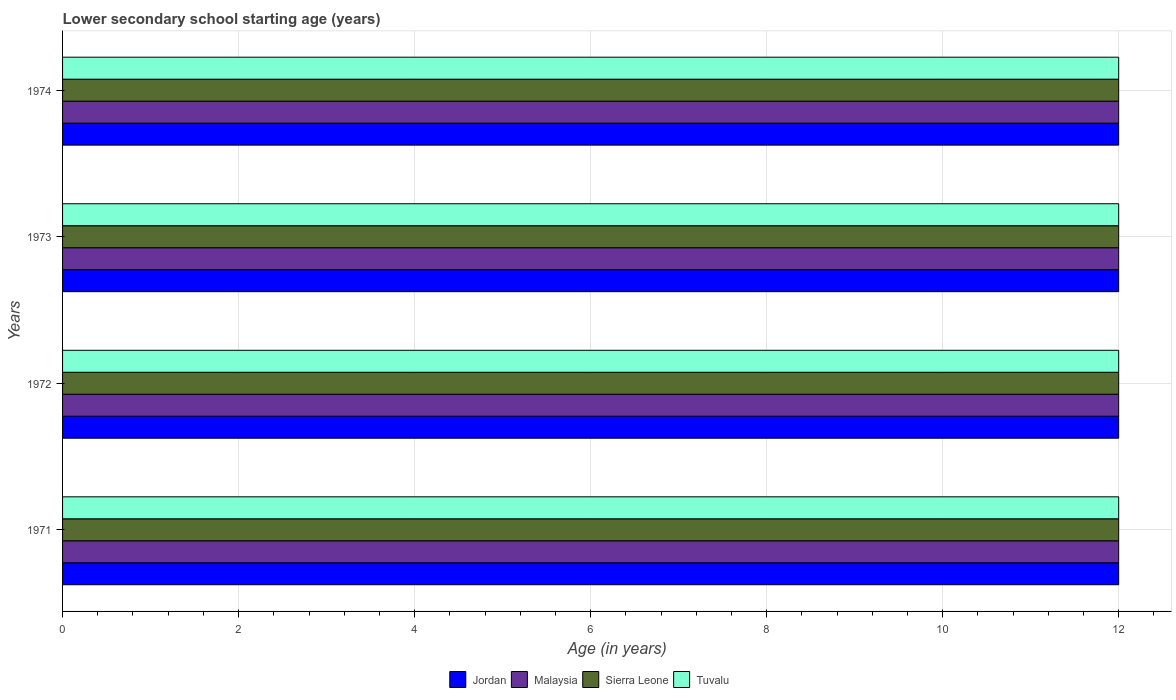How many groups of bars are there?
Provide a succinct answer. 4. Are the number of bars per tick equal to the number of legend labels?
Ensure brevity in your answer.  Yes. Are the number of bars on each tick of the Y-axis equal?
Make the answer very short. Yes. How many bars are there on the 4th tick from the top?
Provide a succinct answer. 4. How many bars are there on the 1st tick from the bottom?
Give a very brief answer. 4. What is the label of the 1st group of bars from the top?
Your answer should be compact. 1974. In how many cases, is the number of bars for a given year not equal to the number of legend labels?
Make the answer very short. 0. What is the lower secondary school starting age of children in Sierra Leone in 1973?
Provide a short and direct response. 12. Across all years, what is the maximum lower secondary school starting age of children in Malaysia?
Your response must be concise. 12. Across all years, what is the minimum lower secondary school starting age of children in Tuvalu?
Keep it short and to the point. 12. What is the total lower secondary school starting age of children in Malaysia in the graph?
Provide a succinct answer. 48. What is the difference between the lower secondary school starting age of children in Jordan in 1971 and that in 1973?
Provide a short and direct response. 0. In how many years, is the lower secondary school starting age of children in Tuvalu greater than 5.6 years?
Keep it short and to the point. 4. What is the difference between the highest and the second highest lower secondary school starting age of children in Sierra Leone?
Ensure brevity in your answer.  0. In how many years, is the lower secondary school starting age of children in Jordan greater than the average lower secondary school starting age of children in Jordan taken over all years?
Offer a very short reply. 0. What does the 3rd bar from the top in 1973 represents?
Keep it short and to the point. Malaysia. What does the 2nd bar from the bottom in 1971 represents?
Your answer should be very brief. Malaysia. Is it the case that in every year, the sum of the lower secondary school starting age of children in Malaysia and lower secondary school starting age of children in Jordan is greater than the lower secondary school starting age of children in Tuvalu?
Your answer should be very brief. Yes. How many bars are there?
Make the answer very short. 16. Are all the bars in the graph horizontal?
Your answer should be very brief. Yes. Are the values on the major ticks of X-axis written in scientific E-notation?
Your answer should be very brief. No. Does the graph contain grids?
Offer a terse response. Yes. Where does the legend appear in the graph?
Ensure brevity in your answer.  Bottom center. How many legend labels are there?
Ensure brevity in your answer.  4. What is the title of the graph?
Give a very brief answer. Lower secondary school starting age (years). What is the label or title of the X-axis?
Ensure brevity in your answer.  Age (in years). What is the Age (in years) in Sierra Leone in 1972?
Ensure brevity in your answer.  12. What is the Age (in years) in Jordan in 1973?
Offer a very short reply. 12. What is the Age (in years) in Malaysia in 1973?
Keep it short and to the point. 12. What is the Age (in years) in Jordan in 1974?
Ensure brevity in your answer.  12. What is the Age (in years) in Malaysia in 1974?
Give a very brief answer. 12. What is the Age (in years) in Tuvalu in 1974?
Offer a terse response. 12. Across all years, what is the maximum Age (in years) of Malaysia?
Your response must be concise. 12. Across all years, what is the maximum Age (in years) of Sierra Leone?
Give a very brief answer. 12. Across all years, what is the maximum Age (in years) in Tuvalu?
Your response must be concise. 12. Across all years, what is the minimum Age (in years) in Jordan?
Ensure brevity in your answer.  12. Across all years, what is the minimum Age (in years) in Malaysia?
Your answer should be compact. 12. Across all years, what is the minimum Age (in years) of Sierra Leone?
Your response must be concise. 12. Across all years, what is the minimum Age (in years) of Tuvalu?
Ensure brevity in your answer.  12. What is the total Age (in years) of Malaysia in the graph?
Your response must be concise. 48. What is the difference between the Age (in years) of Jordan in 1971 and that in 1972?
Provide a short and direct response. 0. What is the difference between the Age (in years) in Malaysia in 1971 and that in 1972?
Provide a succinct answer. 0. What is the difference between the Age (in years) in Sierra Leone in 1971 and that in 1972?
Keep it short and to the point. 0. What is the difference between the Age (in years) in Tuvalu in 1971 and that in 1972?
Provide a short and direct response. 0. What is the difference between the Age (in years) in Jordan in 1971 and that in 1973?
Your answer should be compact. 0. What is the difference between the Age (in years) in Malaysia in 1971 and that in 1973?
Offer a terse response. 0. What is the difference between the Age (in years) of Sierra Leone in 1971 and that in 1973?
Offer a terse response. 0. What is the difference between the Age (in years) of Sierra Leone in 1971 and that in 1974?
Your response must be concise. 0. What is the difference between the Age (in years) in Malaysia in 1972 and that in 1973?
Your answer should be very brief. 0. What is the difference between the Age (in years) in Sierra Leone in 1972 and that in 1973?
Your answer should be compact. 0. What is the difference between the Age (in years) of Tuvalu in 1972 and that in 1973?
Provide a succinct answer. 0. What is the difference between the Age (in years) in Jordan in 1972 and that in 1974?
Offer a terse response. 0. What is the difference between the Age (in years) in Sierra Leone in 1972 and that in 1974?
Give a very brief answer. 0. What is the difference between the Age (in years) of Malaysia in 1973 and that in 1974?
Make the answer very short. 0. What is the difference between the Age (in years) in Sierra Leone in 1973 and that in 1974?
Your response must be concise. 0. What is the difference between the Age (in years) in Jordan in 1971 and the Age (in years) in Sierra Leone in 1972?
Keep it short and to the point. 0. What is the difference between the Age (in years) of Jordan in 1971 and the Age (in years) of Tuvalu in 1972?
Your response must be concise. 0. What is the difference between the Age (in years) of Malaysia in 1971 and the Age (in years) of Sierra Leone in 1972?
Offer a very short reply. 0. What is the difference between the Age (in years) in Malaysia in 1971 and the Age (in years) in Tuvalu in 1972?
Offer a terse response. 0. What is the difference between the Age (in years) of Sierra Leone in 1971 and the Age (in years) of Tuvalu in 1972?
Ensure brevity in your answer.  0. What is the difference between the Age (in years) in Jordan in 1971 and the Age (in years) in Sierra Leone in 1973?
Provide a short and direct response. 0. What is the difference between the Age (in years) of Jordan in 1971 and the Age (in years) of Malaysia in 1974?
Your answer should be compact. 0. What is the difference between the Age (in years) in Jordan in 1971 and the Age (in years) in Tuvalu in 1974?
Provide a succinct answer. 0. What is the difference between the Age (in years) of Malaysia in 1971 and the Age (in years) of Sierra Leone in 1974?
Your response must be concise. 0. What is the difference between the Age (in years) in Malaysia in 1971 and the Age (in years) in Tuvalu in 1974?
Offer a very short reply. 0. What is the difference between the Age (in years) in Sierra Leone in 1971 and the Age (in years) in Tuvalu in 1974?
Make the answer very short. 0. What is the difference between the Age (in years) of Jordan in 1972 and the Age (in years) of Malaysia in 1973?
Your response must be concise. 0. What is the difference between the Age (in years) of Jordan in 1972 and the Age (in years) of Sierra Leone in 1973?
Your answer should be compact. 0. What is the difference between the Age (in years) of Sierra Leone in 1972 and the Age (in years) of Tuvalu in 1973?
Give a very brief answer. 0. What is the difference between the Age (in years) of Jordan in 1972 and the Age (in years) of Tuvalu in 1974?
Ensure brevity in your answer.  0. What is the difference between the Age (in years) in Malaysia in 1972 and the Age (in years) in Sierra Leone in 1974?
Provide a short and direct response. 0. What is the difference between the Age (in years) of Sierra Leone in 1973 and the Age (in years) of Tuvalu in 1974?
Offer a very short reply. 0. What is the average Age (in years) in Malaysia per year?
Provide a short and direct response. 12. What is the average Age (in years) of Sierra Leone per year?
Your answer should be compact. 12. What is the average Age (in years) in Tuvalu per year?
Provide a succinct answer. 12. In the year 1971, what is the difference between the Age (in years) in Malaysia and Age (in years) in Sierra Leone?
Your answer should be very brief. 0. In the year 1971, what is the difference between the Age (in years) in Malaysia and Age (in years) in Tuvalu?
Your response must be concise. 0. In the year 1972, what is the difference between the Age (in years) of Jordan and Age (in years) of Malaysia?
Provide a succinct answer. 0. In the year 1972, what is the difference between the Age (in years) of Jordan and Age (in years) of Sierra Leone?
Provide a short and direct response. 0. In the year 1972, what is the difference between the Age (in years) in Jordan and Age (in years) in Tuvalu?
Keep it short and to the point. 0. In the year 1972, what is the difference between the Age (in years) of Sierra Leone and Age (in years) of Tuvalu?
Offer a very short reply. 0. In the year 1973, what is the difference between the Age (in years) in Jordan and Age (in years) in Malaysia?
Your answer should be very brief. 0. In the year 1973, what is the difference between the Age (in years) of Jordan and Age (in years) of Sierra Leone?
Give a very brief answer. 0. In the year 1973, what is the difference between the Age (in years) of Jordan and Age (in years) of Tuvalu?
Give a very brief answer. 0. In the year 1974, what is the difference between the Age (in years) of Jordan and Age (in years) of Malaysia?
Offer a terse response. 0. In the year 1974, what is the difference between the Age (in years) of Jordan and Age (in years) of Tuvalu?
Offer a very short reply. 0. In the year 1974, what is the difference between the Age (in years) in Malaysia and Age (in years) in Sierra Leone?
Keep it short and to the point. 0. What is the ratio of the Age (in years) of Jordan in 1971 to that in 1972?
Ensure brevity in your answer.  1. What is the ratio of the Age (in years) of Malaysia in 1971 to that in 1972?
Ensure brevity in your answer.  1. What is the ratio of the Age (in years) of Sierra Leone in 1971 to that in 1972?
Ensure brevity in your answer.  1. What is the ratio of the Age (in years) in Sierra Leone in 1971 to that in 1973?
Your response must be concise. 1. What is the ratio of the Age (in years) of Malaysia in 1972 to that in 1974?
Your response must be concise. 1. What is the ratio of the Age (in years) of Tuvalu in 1972 to that in 1974?
Ensure brevity in your answer.  1. What is the ratio of the Age (in years) in Jordan in 1973 to that in 1974?
Ensure brevity in your answer.  1. What is the ratio of the Age (in years) of Malaysia in 1973 to that in 1974?
Your response must be concise. 1. What is the ratio of the Age (in years) in Sierra Leone in 1973 to that in 1974?
Your response must be concise. 1. What is the difference between the highest and the second highest Age (in years) of Jordan?
Make the answer very short. 0. What is the difference between the highest and the second highest Age (in years) in Malaysia?
Your response must be concise. 0. What is the difference between the highest and the second highest Age (in years) of Sierra Leone?
Keep it short and to the point. 0. What is the difference between the highest and the second highest Age (in years) of Tuvalu?
Your answer should be compact. 0. What is the difference between the highest and the lowest Age (in years) of Jordan?
Your answer should be compact. 0. What is the difference between the highest and the lowest Age (in years) in Tuvalu?
Offer a very short reply. 0. 